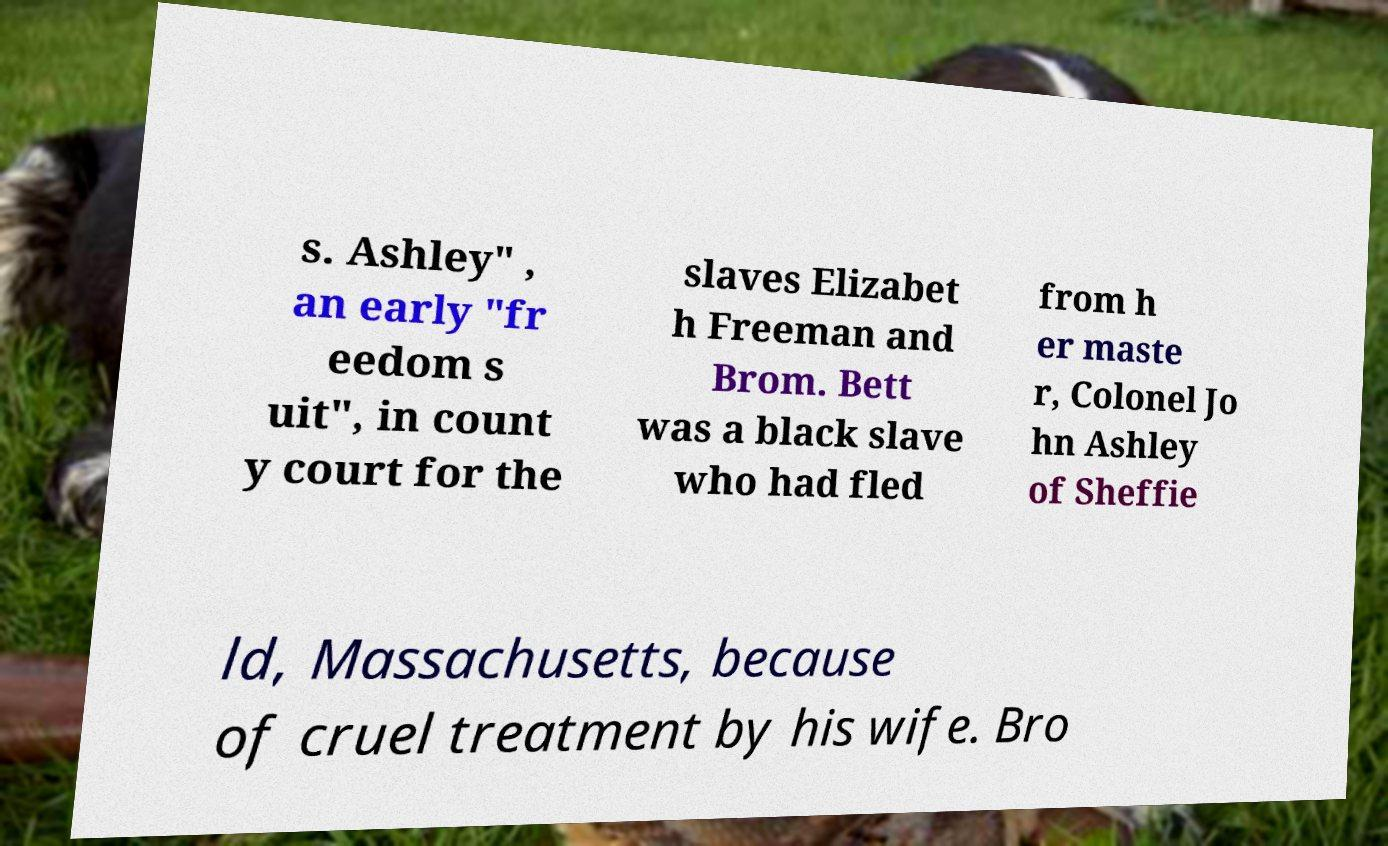Please identify and transcribe the text found in this image. s. Ashley" , an early "fr eedom s uit", in count y court for the slaves Elizabet h Freeman and Brom. Bett was a black slave who had fled from h er maste r, Colonel Jo hn Ashley of Sheffie ld, Massachusetts, because of cruel treatment by his wife. Bro 